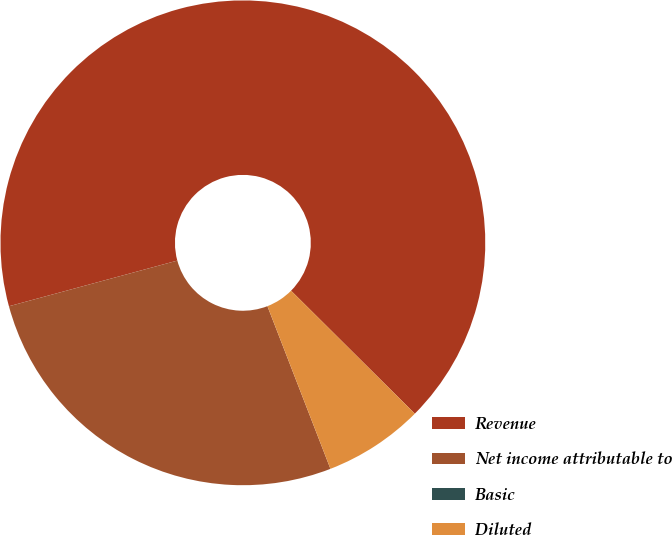Convert chart to OTSL. <chart><loc_0><loc_0><loc_500><loc_500><pie_chart><fcel>Revenue<fcel>Net income attributable to<fcel>Basic<fcel>Diluted<nl><fcel>66.67%<fcel>26.67%<fcel>0.0%<fcel>6.67%<nl></chart> 